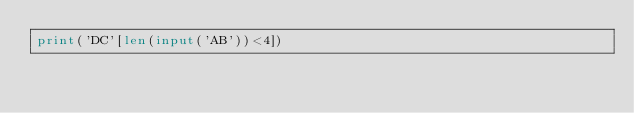Convert code to text. <code><loc_0><loc_0><loc_500><loc_500><_Python_>print('DC'[len(input('AB'))<4])</code> 